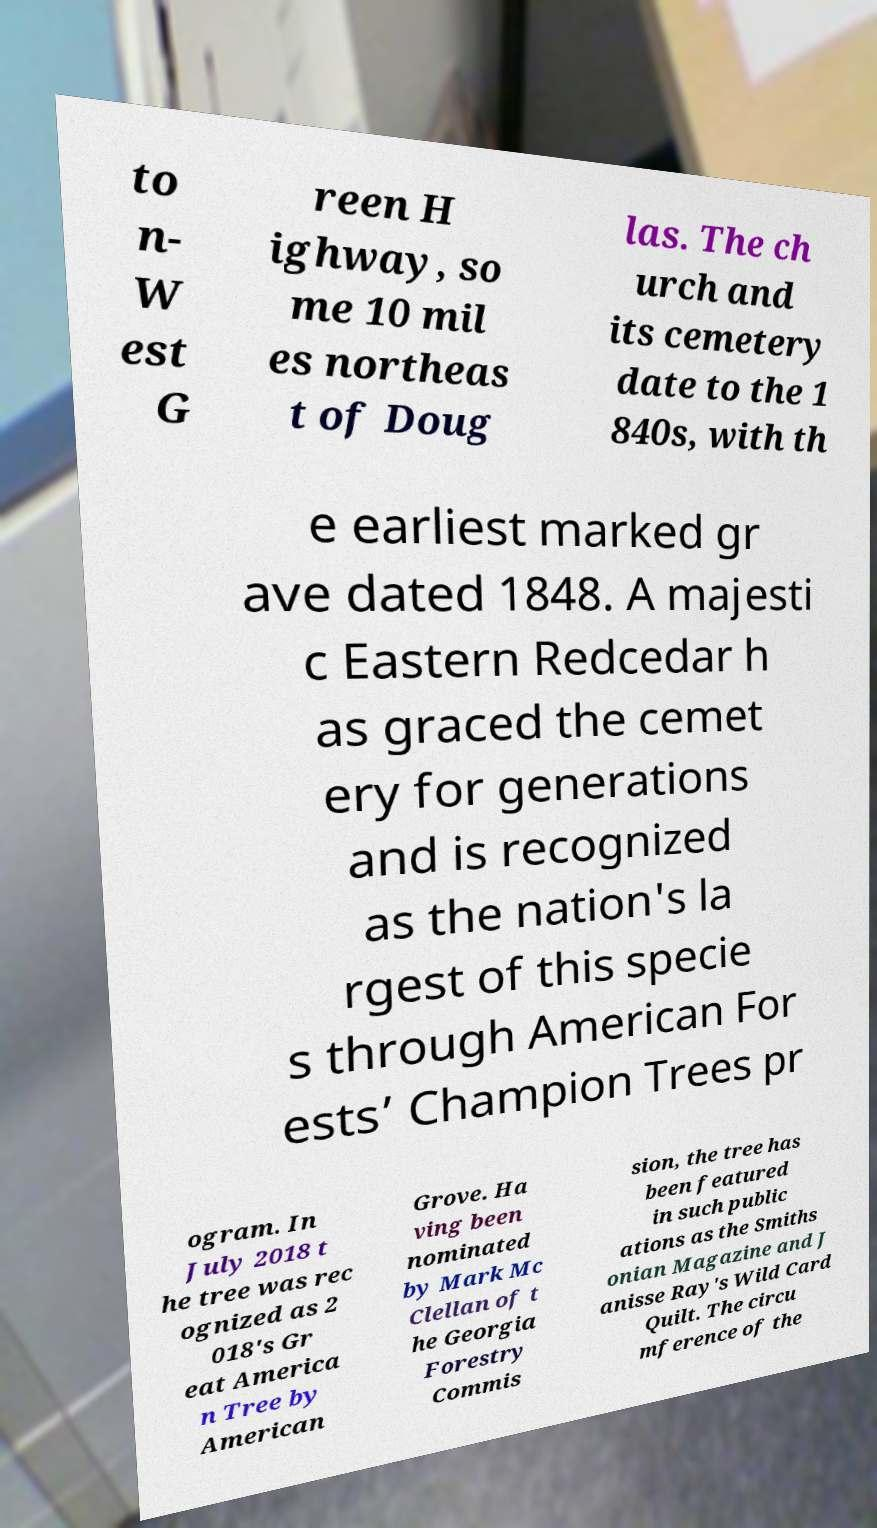What messages or text are displayed in this image? I need them in a readable, typed format. to n- W est G reen H ighway, so me 10 mil es northeas t of Doug las. The ch urch and its cemetery date to the 1 840s, with th e earliest marked gr ave dated 1848. A majesti c Eastern Redcedar h as graced the cemet ery for generations and is recognized as the nation's la rgest of this specie s through American For ests’ Champion Trees pr ogram. In July 2018 t he tree was rec ognized as 2 018's Gr eat America n Tree by American Grove. Ha ving been nominated by Mark Mc Clellan of t he Georgia Forestry Commis sion, the tree has been featured in such public ations as the Smiths onian Magazine and J anisse Ray's Wild Card Quilt. The circu mference of the 